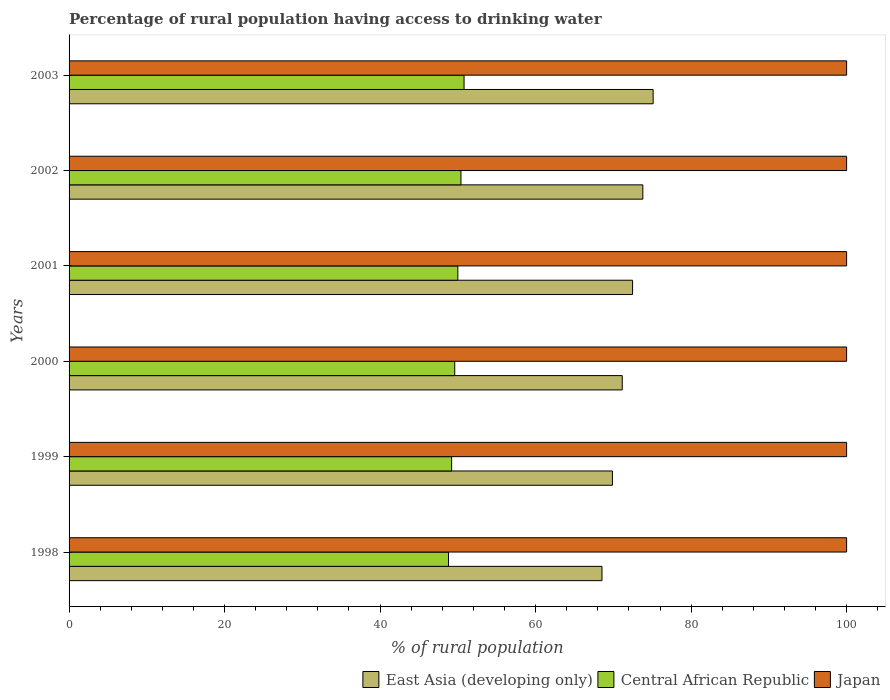How many groups of bars are there?
Your answer should be very brief. 6. Are the number of bars per tick equal to the number of legend labels?
Your response must be concise. Yes. How many bars are there on the 2nd tick from the top?
Your answer should be very brief. 3. How many bars are there on the 3rd tick from the bottom?
Offer a terse response. 3. What is the label of the 4th group of bars from the top?
Make the answer very short. 2000. Across all years, what is the maximum percentage of rural population having access to drinking water in Central African Republic?
Give a very brief answer. 50.8. Across all years, what is the minimum percentage of rural population having access to drinking water in Central African Republic?
Offer a very short reply. 48.8. In which year was the percentage of rural population having access to drinking water in Central African Republic maximum?
Ensure brevity in your answer.  2003. In which year was the percentage of rural population having access to drinking water in East Asia (developing only) minimum?
Offer a terse response. 1998. What is the total percentage of rural population having access to drinking water in East Asia (developing only) in the graph?
Your response must be concise. 430.94. What is the difference between the percentage of rural population having access to drinking water in Japan in 1999 and that in 2001?
Offer a very short reply. 0. What is the difference between the percentage of rural population having access to drinking water in East Asia (developing only) in 1998 and the percentage of rural population having access to drinking water in Japan in 2002?
Provide a succinct answer. -31.46. What is the average percentage of rural population having access to drinking water in Central African Republic per year?
Provide a succinct answer. 49.8. In the year 1998, what is the difference between the percentage of rural population having access to drinking water in Central African Republic and percentage of rural population having access to drinking water in Japan?
Make the answer very short. -51.2. What is the ratio of the percentage of rural population having access to drinking water in Central African Republic in 1999 to that in 2001?
Your response must be concise. 0.98. Is the percentage of rural population having access to drinking water in Japan in 1998 less than that in 2003?
Offer a very short reply. No. Is the difference between the percentage of rural population having access to drinking water in Central African Republic in 1999 and 2000 greater than the difference between the percentage of rural population having access to drinking water in Japan in 1999 and 2000?
Provide a short and direct response. No. What is the difference between the highest and the second highest percentage of rural population having access to drinking water in East Asia (developing only)?
Offer a terse response. 1.32. What is the difference between the highest and the lowest percentage of rural population having access to drinking water in East Asia (developing only)?
Your answer should be compact. 6.58. What does the 2nd bar from the top in 2001 represents?
Ensure brevity in your answer.  Central African Republic. What does the 1st bar from the bottom in 2001 represents?
Your answer should be very brief. East Asia (developing only). Are all the bars in the graph horizontal?
Offer a very short reply. Yes. What is the difference between two consecutive major ticks on the X-axis?
Your answer should be very brief. 20. Does the graph contain any zero values?
Your answer should be compact. No. What is the title of the graph?
Your response must be concise. Percentage of rural population having access to drinking water. What is the label or title of the X-axis?
Give a very brief answer. % of rural population. What is the label or title of the Y-axis?
Your answer should be compact. Years. What is the % of rural population in East Asia (developing only) in 1998?
Keep it short and to the point. 68.54. What is the % of rural population of Central African Republic in 1998?
Offer a terse response. 48.8. What is the % of rural population in Japan in 1998?
Offer a terse response. 100. What is the % of rural population in East Asia (developing only) in 1999?
Ensure brevity in your answer.  69.88. What is the % of rural population of Central African Republic in 1999?
Provide a succinct answer. 49.2. What is the % of rural population in Japan in 1999?
Offer a terse response. 100. What is the % of rural population of East Asia (developing only) in 2000?
Keep it short and to the point. 71.14. What is the % of rural population in Central African Republic in 2000?
Provide a short and direct response. 49.6. What is the % of rural population of East Asia (developing only) in 2001?
Give a very brief answer. 72.47. What is the % of rural population in Central African Republic in 2001?
Your answer should be very brief. 50. What is the % of rural population of Japan in 2001?
Offer a very short reply. 100. What is the % of rural population in East Asia (developing only) in 2002?
Keep it short and to the point. 73.79. What is the % of rural population in Central African Republic in 2002?
Your answer should be very brief. 50.4. What is the % of rural population in Japan in 2002?
Offer a terse response. 100. What is the % of rural population in East Asia (developing only) in 2003?
Give a very brief answer. 75.12. What is the % of rural population of Central African Republic in 2003?
Your answer should be compact. 50.8. Across all years, what is the maximum % of rural population in East Asia (developing only)?
Provide a succinct answer. 75.12. Across all years, what is the maximum % of rural population of Central African Republic?
Your response must be concise. 50.8. Across all years, what is the minimum % of rural population in East Asia (developing only)?
Your answer should be very brief. 68.54. Across all years, what is the minimum % of rural population in Central African Republic?
Your response must be concise. 48.8. What is the total % of rural population in East Asia (developing only) in the graph?
Keep it short and to the point. 430.94. What is the total % of rural population of Central African Republic in the graph?
Keep it short and to the point. 298.8. What is the total % of rural population of Japan in the graph?
Provide a short and direct response. 600. What is the difference between the % of rural population of East Asia (developing only) in 1998 and that in 1999?
Your answer should be compact. -1.34. What is the difference between the % of rural population in Central African Republic in 1998 and that in 1999?
Give a very brief answer. -0.4. What is the difference between the % of rural population of Japan in 1998 and that in 1999?
Offer a very short reply. 0. What is the difference between the % of rural population of East Asia (developing only) in 1998 and that in 2000?
Give a very brief answer. -2.6. What is the difference between the % of rural population of Japan in 1998 and that in 2000?
Your response must be concise. 0. What is the difference between the % of rural population of East Asia (developing only) in 1998 and that in 2001?
Offer a terse response. -3.93. What is the difference between the % of rural population of Japan in 1998 and that in 2001?
Ensure brevity in your answer.  0. What is the difference between the % of rural population of East Asia (developing only) in 1998 and that in 2002?
Make the answer very short. -5.25. What is the difference between the % of rural population in Japan in 1998 and that in 2002?
Provide a succinct answer. 0. What is the difference between the % of rural population in East Asia (developing only) in 1998 and that in 2003?
Give a very brief answer. -6.58. What is the difference between the % of rural population in Central African Republic in 1998 and that in 2003?
Your answer should be compact. -2. What is the difference between the % of rural population in East Asia (developing only) in 1999 and that in 2000?
Your answer should be compact. -1.26. What is the difference between the % of rural population in Japan in 1999 and that in 2000?
Provide a succinct answer. 0. What is the difference between the % of rural population of East Asia (developing only) in 1999 and that in 2001?
Your answer should be very brief. -2.59. What is the difference between the % of rural population in Central African Republic in 1999 and that in 2001?
Your answer should be very brief. -0.8. What is the difference between the % of rural population in East Asia (developing only) in 1999 and that in 2002?
Ensure brevity in your answer.  -3.91. What is the difference between the % of rural population in East Asia (developing only) in 1999 and that in 2003?
Provide a short and direct response. -5.24. What is the difference between the % of rural population of East Asia (developing only) in 2000 and that in 2001?
Provide a succinct answer. -1.33. What is the difference between the % of rural population in East Asia (developing only) in 2000 and that in 2002?
Your response must be concise. -2.65. What is the difference between the % of rural population of Central African Republic in 2000 and that in 2002?
Offer a very short reply. -0.8. What is the difference between the % of rural population of East Asia (developing only) in 2000 and that in 2003?
Ensure brevity in your answer.  -3.97. What is the difference between the % of rural population in East Asia (developing only) in 2001 and that in 2002?
Your answer should be compact. -1.32. What is the difference between the % of rural population in East Asia (developing only) in 2001 and that in 2003?
Your answer should be compact. -2.65. What is the difference between the % of rural population of Central African Republic in 2001 and that in 2003?
Offer a very short reply. -0.8. What is the difference between the % of rural population in East Asia (developing only) in 2002 and that in 2003?
Offer a very short reply. -1.32. What is the difference between the % of rural population of East Asia (developing only) in 1998 and the % of rural population of Central African Republic in 1999?
Your answer should be compact. 19.34. What is the difference between the % of rural population in East Asia (developing only) in 1998 and the % of rural population in Japan in 1999?
Keep it short and to the point. -31.46. What is the difference between the % of rural population in Central African Republic in 1998 and the % of rural population in Japan in 1999?
Offer a terse response. -51.2. What is the difference between the % of rural population in East Asia (developing only) in 1998 and the % of rural population in Central African Republic in 2000?
Offer a terse response. 18.94. What is the difference between the % of rural population of East Asia (developing only) in 1998 and the % of rural population of Japan in 2000?
Ensure brevity in your answer.  -31.46. What is the difference between the % of rural population of Central African Republic in 1998 and the % of rural population of Japan in 2000?
Your answer should be very brief. -51.2. What is the difference between the % of rural population in East Asia (developing only) in 1998 and the % of rural population in Central African Republic in 2001?
Provide a succinct answer. 18.54. What is the difference between the % of rural population of East Asia (developing only) in 1998 and the % of rural population of Japan in 2001?
Your answer should be very brief. -31.46. What is the difference between the % of rural population in Central African Republic in 1998 and the % of rural population in Japan in 2001?
Offer a very short reply. -51.2. What is the difference between the % of rural population in East Asia (developing only) in 1998 and the % of rural population in Central African Republic in 2002?
Your response must be concise. 18.14. What is the difference between the % of rural population of East Asia (developing only) in 1998 and the % of rural population of Japan in 2002?
Ensure brevity in your answer.  -31.46. What is the difference between the % of rural population in Central African Republic in 1998 and the % of rural population in Japan in 2002?
Keep it short and to the point. -51.2. What is the difference between the % of rural population in East Asia (developing only) in 1998 and the % of rural population in Central African Republic in 2003?
Your answer should be very brief. 17.74. What is the difference between the % of rural population of East Asia (developing only) in 1998 and the % of rural population of Japan in 2003?
Your response must be concise. -31.46. What is the difference between the % of rural population of Central African Republic in 1998 and the % of rural population of Japan in 2003?
Offer a terse response. -51.2. What is the difference between the % of rural population in East Asia (developing only) in 1999 and the % of rural population in Central African Republic in 2000?
Your response must be concise. 20.28. What is the difference between the % of rural population in East Asia (developing only) in 1999 and the % of rural population in Japan in 2000?
Ensure brevity in your answer.  -30.12. What is the difference between the % of rural population of Central African Republic in 1999 and the % of rural population of Japan in 2000?
Your answer should be very brief. -50.8. What is the difference between the % of rural population of East Asia (developing only) in 1999 and the % of rural population of Central African Republic in 2001?
Give a very brief answer. 19.88. What is the difference between the % of rural population of East Asia (developing only) in 1999 and the % of rural population of Japan in 2001?
Provide a succinct answer. -30.12. What is the difference between the % of rural population of Central African Republic in 1999 and the % of rural population of Japan in 2001?
Ensure brevity in your answer.  -50.8. What is the difference between the % of rural population of East Asia (developing only) in 1999 and the % of rural population of Central African Republic in 2002?
Your answer should be compact. 19.48. What is the difference between the % of rural population in East Asia (developing only) in 1999 and the % of rural population in Japan in 2002?
Your answer should be very brief. -30.12. What is the difference between the % of rural population in Central African Republic in 1999 and the % of rural population in Japan in 2002?
Make the answer very short. -50.8. What is the difference between the % of rural population of East Asia (developing only) in 1999 and the % of rural population of Central African Republic in 2003?
Provide a succinct answer. 19.08. What is the difference between the % of rural population in East Asia (developing only) in 1999 and the % of rural population in Japan in 2003?
Offer a terse response. -30.12. What is the difference between the % of rural population in Central African Republic in 1999 and the % of rural population in Japan in 2003?
Your response must be concise. -50.8. What is the difference between the % of rural population in East Asia (developing only) in 2000 and the % of rural population in Central African Republic in 2001?
Provide a short and direct response. 21.14. What is the difference between the % of rural population in East Asia (developing only) in 2000 and the % of rural population in Japan in 2001?
Provide a short and direct response. -28.86. What is the difference between the % of rural population in Central African Republic in 2000 and the % of rural population in Japan in 2001?
Give a very brief answer. -50.4. What is the difference between the % of rural population of East Asia (developing only) in 2000 and the % of rural population of Central African Republic in 2002?
Offer a terse response. 20.74. What is the difference between the % of rural population of East Asia (developing only) in 2000 and the % of rural population of Japan in 2002?
Offer a very short reply. -28.86. What is the difference between the % of rural population of Central African Republic in 2000 and the % of rural population of Japan in 2002?
Your answer should be compact. -50.4. What is the difference between the % of rural population in East Asia (developing only) in 2000 and the % of rural population in Central African Republic in 2003?
Your answer should be compact. 20.34. What is the difference between the % of rural population of East Asia (developing only) in 2000 and the % of rural population of Japan in 2003?
Make the answer very short. -28.86. What is the difference between the % of rural population in Central African Republic in 2000 and the % of rural population in Japan in 2003?
Offer a very short reply. -50.4. What is the difference between the % of rural population in East Asia (developing only) in 2001 and the % of rural population in Central African Republic in 2002?
Provide a short and direct response. 22.07. What is the difference between the % of rural population in East Asia (developing only) in 2001 and the % of rural population in Japan in 2002?
Your response must be concise. -27.53. What is the difference between the % of rural population of Central African Republic in 2001 and the % of rural population of Japan in 2002?
Provide a succinct answer. -50. What is the difference between the % of rural population in East Asia (developing only) in 2001 and the % of rural population in Central African Republic in 2003?
Ensure brevity in your answer.  21.67. What is the difference between the % of rural population in East Asia (developing only) in 2001 and the % of rural population in Japan in 2003?
Keep it short and to the point. -27.53. What is the difference between the % of rural population of East Asia (developing only) in 2002 and the % of rural population of Central African Republic in 2003?
Offer a very short reply. 22.99. What is the difference between the % of rural population of East Asia (developing only) in 2002 and the % of rural population of Japan in 2003?
Your response must be concise. -26.21. What is the difference between the % of rural population of Central African Republic in 2002 and the % of rural population of Japan in 2003?
Offer a terse response. -49.6. What is the average % of rural population in East Asia (developing only) per year?
Your answer should be compact. 71.82. What is the average % of rural population in Central African Republic per year?
Give a very brief answer. 49.8. In the year 1998, what is the difference between the % of rural population in East Asia (developing only) and % of rural population in Central African Republic?
Ensure brevity in your answer.  19.74. In the year 1998, what is the difference between the % of rural population of East Asia (developing only) and % of rural population of Japan?
Your response must be concise. -31.46. In the year 1998, what is the difference between the % of rural population of Central African Republic and % of rural population of Japan?
Give a very brief answer. -51.2. In the year 1999, what is the difference between the % of rural population of East Asia (developing only) and % of rural population of Central African Republic?
Your response must be concise. 20.68. In the year 1999, what is the difference between the % of rural population in East Asia (developing only) and % of rural population in Japan?
Give a very brief answer. -30.12. In the year 1999, what is the difference between the % of rural population in Central African Republic and % of rural population in Japan?
Provide a short and direct response. -50.8. In the year 2000, what is the difference between the % of rural population in East Asia (developing only) and % of rural population in Central African Republic?
Give a very brief answer. 21.54. In the year 2000, what is the difference between the % of rural population in East Asia (developing only) and % of rural population in Japan?
Keep it short and to the point. -28.86. In the year 2000, what is the difference between the % of rural population of Central African Republic and % of rural population of Japan?
Offer a terse response. -50.4. In the year 2001, what is the difference between the % of rural population of East Asia (developing only) and % of rural population of Central African Republic?
Ensure brevity in your answer.  22.47. In the year 2001, what is the difference between the % of rural population of East Asia (developing only) and % of rural population of Japan?
Ensure brevity in your answer.  -27.53. In the year 2002, what is the difference between the % of rural population of East Asia (developing only) and % of rural population of Central African Republic?
Keep it short and to the point. 23.39. In the year 2002, what is the difference between the % of rural population of East Asia (developing only) and % of rural population of Japan?
Offer a very short reply. -26.21. In the year 2002, what is the difference between the % of rural population in Central African Republic and % of rural population in Japan?
Provide a short and direct response. -49.6. In the year 2003, what is the difference between the % of rural population in East Asia (developing only) and % of rural population in Central African Republic?
Offer a very short reply. 24.32. In the year 2003, what is the difference between the % of rural population in East Asia (developing only) and % of rural population in Japan?
Provide a succinct answer. -24.88. In the year 2003, what is the difference between the % of rural population in Central African Republic and % of rural population in Japan?
Give a very brief answer. -49.2. What is the ratio of the % of rural population in East Asia (developing only) in 1998 to that in 1999?
Ensure brevity in your answer.  0.98. What is the ratio of the % of rural population in Central African Republic in 1998 to that in 1999?
Give a very brief answer. 0.99. What is the ratio of the % of rural population in Japan in 1998 to that in 1999?
Ensure brevity in your answer.  1. What is the ratio of the % of rural population in East Asia (developing only) in 1998 to that in 2000?
Your response must be concise. 0.96. What is the ratio of the % of rural population in Central African Republic in 1998 to that in 2000?
Ensure brevity in your answer.  0.98. What is the ratio of the % of rural population in East Asia (developing only) in 1998 to that in 2001?
Your response must be concise. 0.95. What is the ratio of the % of rural population in Central African Republic in 1998 to that in 2001?
Ensure brevity in your answer.  0.98. What is the ratio of the % of rural population of East Asia (developing only) in 1998 to that in 2002?
Keep it short and to the point. 0.93. What is the ratio of the % of rural population of Central African Republic in 1998 to that in 2002?
Offer a very short reply. 0.97. What is the ratio of the % of rural population in East Asia (developing only) in 1998 to that in 2003?
Make the answer very short. 0.91. What is the ratio of the % of rural population of Central African Republic in 1998 to that in 2003?
Your answer should be very brief. 0.96. What is the ratio of the % of rural population in East Asia (developing only) in 1999 to that in 2000?
Your answer should be compact. 0.98. What is the ratio of the % of rural population in Japan in 1999 to that in 2000?
Your response must be concise. 1. What is the ratio of the % of rural population in East Asia (developing only) in 1999 to that in 2001?
Make the answer very short. 0.96. What is the ratio of the % of rural population in East Asia (developing only) in 1999 to that in 2002?
Provide a short and direct response. 0.95. What is the ratio of the % of rural population of Central African Republic in 1999 to that in 2002?
Provide a short and direct response. 0.98. What is the ratio of the % of rural population of Japan in 1999 to that in 2002?
Your answer should be compact. 1. What is the ratio of the % of rural population of East Asia (developing only) in 1999 to that in 2003?
Offer a terse response. 0.93. What is the ratio of the % of rural population of Central African Republic in 1999 to that in 2003?
Give a very brief answer. 0.97. What is the ratio of the % of rural population of Japan in 1999 to that in 2003?
Give a very brief answer. 1. What is the ratio of the % of rural population in East Asia (developing only) in 2000 to that in 2001?
Offer a very short reply. 0.98. What is the ratio of the % of rural population in East Asia (developing only) in 2000 to that in 2002?
Provide a succinct answer. 0.96. What is the ratio of the % of rural population in Central African Republic in 2000 to that in 2002?
Provide a succinct answer. 0.98. What is the ratio of the % of rural population of East Asia (developing only) in 2000 to that in 2003?
Your answer should be compact. 0.95. What is the ratio of the % of rural population of Central African Republic in 2000 to that in 2003?
Offer a very short reply. 0.98. What is the ratio of the % of rural population in Japan in 2000 to that in 2003?
Offer a very short reply. 1. What is the ratio of the % of rural population of East Asia (developing only) in 2001 to that in 2002?
Provide a short and direct response. 0.98. What is the ratio of the % of rural population in East Asia (developing only) in 2001 to that in 2003?
Provide a succinct answer. 0.96. What is the ratio of the % of rural population of Central African Republic in 2001 to that in 2003?
Offer a very short reply. 0.98. What is the ratio of the % of rural population of East Asia (developing only) in 2002 to that in 2003?
Give a very brief answer. 0.98. What is the ratio of the % of rural population of Central African Republic in 2002 to that in 2003?
Your response must be concise. 0.99. What is the difference between the highest and the second highest % of rural population in East Asia (developing only)?
Offer a terse response. 1.32. What is the difference between the highest and the second highest % of rural population of Central African Republic?
Make the answer very short. 0.4. What is the difference between the highest and the lowest % of rural population of East Asia (developing only)?
Offer a very short reply. 6.58. What is the difference between the highest and the lowest % of rural population of Japan?
Your answer should be compact. 0. 